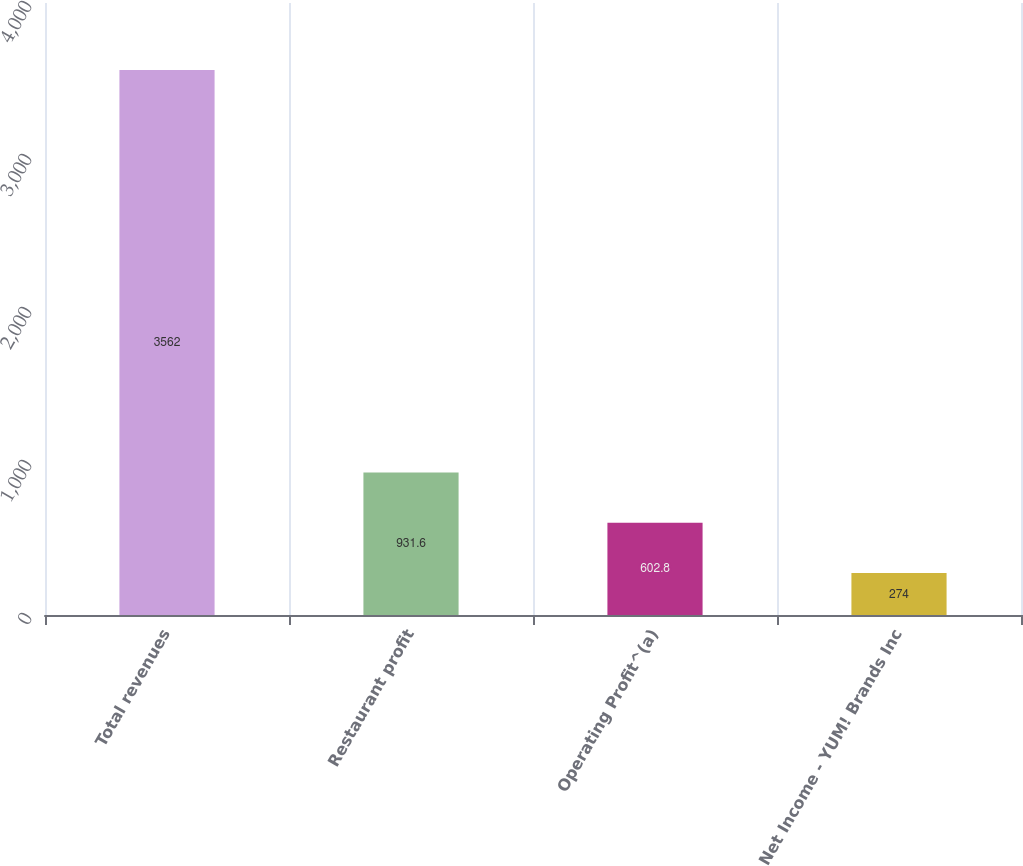<chart> <loc_0><loc_0><loc_500><loc_500><bar_chart><fcel>Total revenues<fcel>Restaurant profit<fcel>Operating Profit^(a)<fcel>Net Income - YUM! Brands Inc<nl><fcel>3562<fcel>931.6<fcel>602.8<fcel>274<nl></chart> 